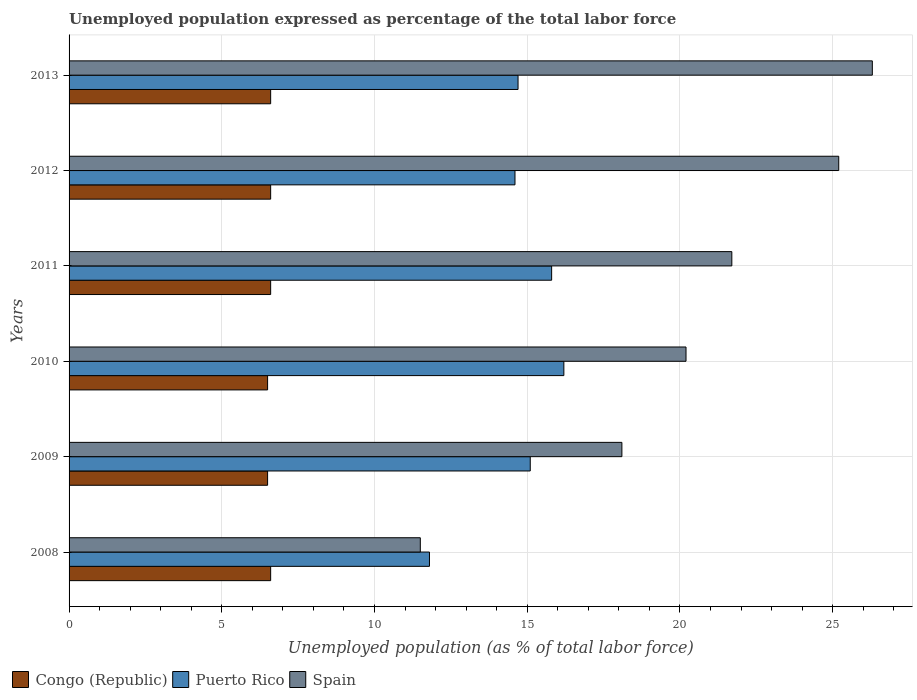Are the number of bars on each tick of the Y-axis equal?
Ensure brevity in your answer.  Yes. How many bars are there on the 3rd tick from the top?
Offer a very short reply. 3. How many bars are there on the 1st tick from the bottom?
Offer a terse response. 3. What is the unemployment in in Puerto Rico in 2012?
Offer a very short reply. 14.6. Across all years, what is the maximum unemployment in in Congo (Republic)?
Your answer should be compact. 6.6. In which year was the unemployment in in Puerto Rico maximum?
Offer a very short reply. 2010. In which year was the unemployment in in Spain minimum?
Offer a terse response. 2008. What is the total unemployment in in Puerto Rico in the graph?
Your answer should be very brief. 88.2. What is the difference between the unemployment in in Spain in 2008 and that in 2010?
Give a very brief answer. -8.7. What is the difference between the unemployment in in Puerto Rico in 2010 and the unemployment in in Spain in 2009?
Your answer should be compact. -1.9. What is the average unemployment in in Puerto Rico per year?
Ensure brevity in your answer.  14.7. In the year 2012, what is the difference between the unemployment in in Puerto Rico and unemployment in in Congo (Republic)?
Your answer should be compact. 8. What is the ratio of the unemployment in in Puerto Rico in 2011 to that in 2012?
Provide a succinct answer. 1.08. Is the unemployment in in Puerto Rico in 2008 less than that in 2012?
Your answer should be compact. Yes. What is the difference between the highest and the lowest unemployment in in Spain?
Your answer should be very brief. 14.8. In how many years, is the unemployment in in Spain greater than the average unemployment in in Spain taken over all years?
Offer a terse response. 3. What does the 2nd bar from the top in 2008 represents?
Make the answer very short. Puerto Rico. What does the 2nd bar from the bottom in 2010 represents?
Your answer should be very brief. Puerto Rico. How many bars are there?
Your response must be concise. 18. How many years are there in the graph?
Make the answer very short. 6. What is the difference between two consecutive major ticks on the X-axis?
Provide a succinct answer. 5. Where does the legend appear in the graph?
Provide a succinct answer. Bottom left. How many legend labels are there?
Keep it short and to the point. 3. What is the title of the graph?
Give a very brief answer. Unemployed population expressed as percentage of the total labor force. Does "Austria" appear as one of the legend labels in the graph?
Offer a terse response. No. What is the label or title of the X-axis?
Make the answer very short. Unemployed population (as % of total labor force). What is the Unemployed population (as % of total labor force) of Congo (Republic) in 2008?
Keep it short and to the point. 6.6. What is the Unemployed population (as % of total labor force) in Puerto Rico in 2008?
Offer a very short reply. 11.8. What is the Unemployed population (as % of total labor force) of Spain in 2008?
Your answer should be very brief. 11.5. What is the Unemployed population (as % of total labor force) in Puerto Rico in 2009?
Make the answer very short. 15.1. What is the Unemployed population (as % of total labor force) of Spain in 2009?
Your answer should be very brief. 18.1. What is the Unemployed population (as % of total labor force) of Puerto Rico in 2010?
Provide a short and direct response. 16.2. What is the Unemployed population (as % of total labor force) in Spain in 2010?
Make the answer very short. 20.2. What is the Unemployed population (as % of total labor force) of Congo (Republic) in 2011?
Your answer should be compact. 6.6. What is the Unemployed population (as % of total labor force) in Puerto Rico in 2011?
Offer a terse response. 15.8. What is the Unemployed population (as % of total labor force) in Spain in 2011?
Make the answer very short. 21.7. What is the Unemployed population (as % of total labor force) in Congo (Republic) in 2012?
Your answer should be very brief. 6.6. What is the Unemployed population (as % of total labor force) of Puerto Rico in 2012?
Your answer should be very brief. 14.6. What is the Unemployed population (as % of total labor force) in Spain in 2012?
Give a very brief answer. 25.2. What is the Unemployed population (as % of total labor force) of Congo (Republic) in 2013?
Offer a terse response. 6.6. What is the Unemployed population (as % of total labor force) in Puerto Rico in 2013?
Your response must be concise. 14.7. What is the Unemployed population (as % of total labor force) of Spain in 2013?
Ensure brevity in your answer.  26.3. Across all years, what is the maximum Unemployed population (as % of total labor force) of Congo (Republic)?
Your answer should be compact. 6.6. Across all years, what is the maximum Unemployed population (as % of total labor force) of Puerto Rico?
Keep it short and to the point. 16.2. Across all years, what is the maximum Unemployed population (as % of total labor force) of Spain?
Provide a short and direct response. 26.3. Across all years, what is the minimum Unemployed population (as % of total labor force) of Congo (Republic)?
Your answer should be compact. 6.5. Across all years, what is the minimum Unemployed population (as % of total labor force) of Puerto Rico?
Your response must be concise. 11.8. What is the total Unemployed population (as % of total labor force) of Congo (Republic) in the graph?
Make the answer very short. 39.4. What is the total Unemployed population (as % of total labor force) in Puerto Rico in the graph?
Your response must be concise. 88.2. What is the total Unemployed population (as % of total labor force) of Spain in the graph?
Provide a short and direct response. 123. What is the difference between the Unemployed population (as % of total labor force) in Spain in 2008 and that in 2009?
Make the answer very short. -6.6. What is the difference between the Unemployed population (as % of total labor force) of Congo (Republic) in 2008 and that in 2010?
Make the answer very short. 0.1. What is the difference between the Unemployed population (as % of total labor force) of Spain in 2008 and that in 2010?
Your response must be concise. -8.7. What is the difference between the Unemployed population (as % of total labor force) of Congo (Republic) in 2008 and that in 2011?
Your response must be concise. 0. What is the difference between the Unemployed population (as % of total labor force) in Puerto Rico in 2008 and that in 2012?
Offer a very short reply. -2.8. What is the difference between the Unemployed population (as % of total labor force) of Spain in 2008 and that in 2012?
Give a very brief answer. -13.7. What is the difference between the Unemployed population (as % of total labor force) in Congo (Republic) in 2008 and that in 2013?
Your answer should be compact. 0. What is the difference between the Unemployed population (as % of total labor force) in Puerto Rico in 2008 and that in 2013?
Your answer should be compact. -2.9. What is the difference between the Unemployed population (as % of total labor force) of Spain in 2008 and that in 2013?
Your answer should be very brief. -14.8. What is the difference between the Unemployed population (as % of total labor force) of Congo (Republic) in 2009 and that in 2010?
Offer a terse response. 0. What is the difference between the Unemployed population (as % of total labor force) in Puerto Rico in 2009 and that in 2010?
Provide a short and direct response. -1.1. What is the difference between the Unemployed population (as % of total labor force) of Spain in 2009 and that in 2010?
Ensure brevity in your answer.  -2.1. What is the difference between the Unemployed population (as % of total labor force) of Congo (Republic) in 2009 and that in 2011?
Give a very brief answer. -0.1. What is the difference between the Unemployed population (as % of total labor force) in Puerto Rico in 2009 and that in 2011?
Ensure brevity in your answer.  -0.7. What is the difference between the Unemployed population (as % of total labor force) of Puerto Rico in 2009 and that in 2012?
Provide a succinct answer. 0.5. What is the difference between the Unemployed population (as % of total labor force) of Spain in 2009 and that in 2012?
Your response must be concise. -7.1. What is the difference between the Unemployed population (as % of total labor force) of Spain in 2009 and that in 2013?
Your answer should be compact. -8.2. What is the difference between the Unemployed population (as % of total labor force) of Congo (Republic) in 2010 and that in 2012?
Ensure brevity in your answer.  -0.1. What is the difference between the Unemployed population (as % of total labor force) of Puerto Rico in 2010 and that in 2012?
Your response must be concise. 1.6. What is the difference between the Unemployed population (as % of total labor force) in Congo (Republic) in 2010 and that in 2013?
Your answer should be compact. -0.1. What is the difference between the Unemployed population (as % of total labor force) in Spain in 2010 and that in 2013?
Keep it short and to the point. -6.1. What is the difference between the Unemployed population (as % of total labor force) in Congo (Republic) in 2011 and that in 2012?
Your answer should be compact. 0. What is the difference between the Unemployed population (as % of total labor force) in Puerto Rico in 2011 and that in 2012?
Make the answer very short. 1.2. What is the difference between the Unemployed population (as % of total labor force) of Congo (Republic) in 2011 and that in 2013?
Provide a short and direct response. 0. What is the difference between the Unemployed population (as % of total labor force) of Puerto Rico in 2011 and that in 2013?
Your response must be concise. 1.1. What is the difference between the Unemployed population (as % of total labor force) in Spain in 2011 and that in 2013?
Ensure brevity in your answer.  -4.6. What is the difference between the Unemployed population (as % of total labor force) in Congo (Republic) in 2012 and that in 2013?
Make the answer very short. 0. What is the difference between the Unemployed population (as % of total labor force) of Congo (Republic) in 2008 and the Unemployed population (as % of total labor force) of Spain in 2009?
Provide a short and direct response. -11.5. What is the difference between the Unemployed population (as % of total labor force) in Congo (Republic) in 2008 and the Unemployed population (as % of total labor force) in Puerto Rico in 2010?
Ensure brevity in your answer.  -9.6. What is the difference between the Unemployed population (as % of total labor force) in Congo (Republic) in 2008 and the Unemployed population (as % of total labor force) in Spain in 2010?
Keep it short and to the point. -13.6. What is the difference between the Unemployed population (as % of total labor force) of Congo (Republic) in 2008 and the Unemployed population (as % of total labor force) of Puerto Rico in 2011?
Provide a short and direct response. -9.2. What is the difference between the Unemployed population (as % of total labor force) in Congo (Republic) in 2008 and the Unemployed population (as % of total labor force) in Spain in 2011?
Keep it short and to the point. -15.1. What is the difference between the Unemployed population (as % of total labor force) in Puerto Rico in 2008 and the Unemployed population (as % of total labor force) in Spain in 2011?
Offer a very short reply. -9.9. What is the difference between the Unemployed population (as % of total labor force) of Congo (Republic) in 2008 and the Unemployed population (as % of total labor force) of Puerto Rico in 2012?
Provide a succinct answer. -8. What is the difference between the Unemployed population (as % of total labor force) in Congo (Republic) in 2008 and the Unemployed population (as % of total labor force) in Spain in 2012?
Make the answer very short. -18.6. What is the difference between the Unemployed population (as % of total labor force) of Puerto Rico in 2008 and the Unemployed population (as % of total labor force) of Spain in 2012?
Your answer should be very brief. -13.4. What is the difference between the Unemployed population (as % of total labor force) of Congo (Republic) in 2008 and the Unemployed population (as % of total labor force) of Spain in 2013?
Your response must be concise. -19.7. What is the difference between the Unemployed population (as % of total labor force) in Puerto Rico in 2008 and the Unemployed population (as % of total labor force) in Spain in 2013?
Provide a short and direct response. -14.5. What is the difference between the Unemployed population (as % of total labor force) of Congo (Republic) in 2009 and the Unemployed population (as % of total labor force) of Puerto Rico in 2010?
Offer a very short reply. -9.7. What is the difference between the Unemployed population (as % of total labor force) in Congo (Republic) in 2009 and the Unemployed population (as % of total labor force) in Spain in 2010?
Give a very brief answer. -13.7. What is the difference between the Unemployed population (as % of total labor force) in Puerto Rico in 2009 and the Unemployed population (as % of total labor force) in Spain in 2010?
Give a very brief answer. -5.1. What is the difference between the Unemployed population (as % of total labor force) in Congo (Republic) in 2009 and the Unemployed population (as % of total labor force) in Spain in 2011?
Offer a terse response. -15.2. What is the difference between the Unemployed population (as % of total labor force) in Congo (Republic) in 2009 and the Unemployed population (as % of total labor force) in Puerto Rico in 2012?
Offer a very short reply. -8.1. What is the difference between the Unemployed population (as % of total labor force) of Congo (Republic) in 2009 and the Unemployed population (as % of total labor force) of Spain in 2012?
Offer a very short reply. -18.7. What is the difference between the Unemployed population (as % of total labor force) of Congo (Republic) in 2009 and the Unemployed population (as % of total labor force) of Puerto Rico in 2013?
Provide a short and direct response. -8.2. What is the difference between the Unemployed population (as % of total labor force) of Congo (Republic) in 2009 and the Unemployed population (as % of total labor force) of Spain in 2013?
Ensure brevity in your answer.  -19.8. What is the difference between the Unemployed population (as % of total labor force) in Puerto Rico in 2009 and the Unemployed population (as % of total labor force) in Spain in 2013?
Your answer should be compact. -11.2. What is the difference between the Unemployed population (as % of total labor force) in Congo (Republic) in 2010 and the Unemployed population (as % of total labor force) in Puerto Rico in 2011?
Provide a succinct answer. -9.3. What is the difference between the Unemployed population (as % of total labor force) of Congo (Republic) in 2010 and the Unemployed population (as % of total labor force) of Spain in 2011?
Offer a very short reply. -15.2. What is the difference between the Unemployed population (as % of total labor force) of Congo (Republic) in 2010 and the Unemployed population (as % of total labor force) of Puerto Rico in 2012?
Provide a succinct answer. -8.1. What is the difference between the Unemployed population (as % of total labor force) of Congo (Republic) in 2010 and the Unemployed population (as % of total labor force) of Spain in 2012?
Give a very brief answer. -18.7. What is the difference between the Unemployed population (as % of total labor force) of Puerto Rico in 2010 and the Unemployed population (as % of total labor force) of Spain in 2012?
Provide a short and direct response. -9. What is the difference between the Unemployed population (as % of total labor force) of Congo (Republic) in 2010 and the Unemployed population (as % of total labor force) of Puerto Rico in 2013?
Give a very brief answer. -8.2. What is the difference between the Unemployed population (as % of total labor force) in Congo (Republic) in 2010 and the Unemployed population (as % of total labor force) in Spain in 2013?
Offer a terse response. -19.8. What is the difference between the Unemployed population (as % of total labor force) of Puerto Rico in 2010 and the Unemployed population (as % of total labor force) of Spain in 2013?
Your answer should be compact. -10.1. What is the difference between the Unemployed population (as % of total labor force) in Congo (Republic) in 2011 and the Unemployed population (as % of total labor force) in Spain in 2012?
Offer a terse response. -18.6. What is the difference between the Unemployed population (as % of total labor force) of Congo (Republic) in 2011 and the Unemployed population (as % of total labor force) of Puerto Rico in 2013?
Offer a terse response. -8.1. What is the difference between the Unemployed population (as % of total labor force) of Congo (Republic) in 2011 and the Unemployed population (as % of total labor force) of Spain in 2013?
Keep it short and to the point. -19.7. What is the difference between the Unemployed population (as % of total labor force) in Puerto Rico in 2011 and the Unemployed population (as % of total labor force) in Spain in 2013?
Keep it short and to the point. -10.5. What is the difference between the Unemployed population (as % of total labor force) in Congo (Republic) in 2012 and the Unemployed population (as % of total labor force) in Spain in 2013?
Provide a succinct answer. -19.7. What is the difference between the Unemployed population (as % of total labor force) in Puerto Rico in 2012 and the Unemployed population (as % of total labor force) in Spain in 2013?
Your answer should be compact. -11.7. What is the average Unemployed population (as % of total labor force) of Congo (Republic) per year?
Give a very brief answer. 6.57. What is the average Unemployed population (as % of total labor force) of Puerto Rico per year?
Ensure brevity in your answer.  14.7. In the year 2008, what is the difference between the Unemployed population (as % of total labor force) of Congo (Republic) and Unemployed population (as % of total labor force) of Spain?
Provide a short and direct response. -4.9. In the year 2008, what is the difference between the Unemployed population (as % of total labor force) of Puerto Rico and Unemployed population (as % of total labor force) of Spain?
Keep it short and to the point. 0.3. In the year 2009, what is the difference between the Unemployed population (as % of total labor force) in Congo (Republic) and Unemployed population (as % of total labor force) in Puerto Rico?
Your response must be concise. -8.6. In the year 2009, what is the difference between the Unemployed population (as % of total labor force) of Congo (Republic) and Unemployed population (as % of total labor force) of Spain?
Provide a succinct answer. -11.6. In the year 2010, what is the difference between the Unemployed population (as % of total labor force) in Congo (Republic) and Unemployed population (as % of total labor force) in Puerto Rico?
Your answer should be very brief. -9.7. In the year 2010, what is the difference between the Unemployed population (as % of total labor force) in Congo (Republic) and Unemployed population (as % of total labor force) in Spain?
Your response must be concise. -13.7. In the year 2010, what is the difference between the Unemployed population (as % of total labor force) in Puerto Rico and Unemployed population (as % of total labor force) in Spain?
Offer a terse response. -4. In the year 2011, what is the difference between the Unemployed population (as % of total labor force) of Congo (Republic) and Unemployed population (as % of total labor force) of Puerto Rico?
Keep it short and to the point. -9.2. In the year 2011, what is the difference between the Unemployed population (as % of total labor force) of Congo (Republic) and Unemployed population (as % of total labor force) of Spain?
Your answer should be compact. -15.1. In the year 2012, what is the difference between the Unemployed population (as % of total labor force) in Congo (Republic) and Unemployed population (as % of total labor force) in Puerto Rico?
Make the answer very short. -8. In the year 2012, what is the difference between the Unemployed population (as % of total labor force) in Congo (Republic) and Unemployed population (as % of total labor force) in Spain?
Your response must be concise. -18.6. In the year 2012, what is the difference between the Unemployed population (as % of total labor force) of Puerto Rico and Unemployed population (as % of total labor force) of Spain?
Your answer should be very brief. -10.6. In the year 2013, what is the difference between the Unemployed population (as % of total labor force) in Congo (Republic) and Unemployed population (as % of total labor force) in Puerto Rico?
Keep it short and to the point. -8.1. In the year 2013, what is the difference between the Unemployed population (as % of total labor force) in Congo (Republic) and Unemployed population (as % of total labor force) in Spain?
Provide a succinct answer. -19.7. In the year 2013, what is the difference between the Unemployed population (as % of total labor force) in Puerto Rico and Unemployed population (as % of total labor force) in Spain?
Provide a short and direct response. -11.6. What is the ratio of the Unemployed population (as % of total labor force) in Congo (Republic) in 2008 to that in 2009?
Ensure brevity in your answer.  1.02. What is the ratio of the Unemployed population (as % of total labor force) in Puerto Rico in 2008 to that in 2009?
Your answer should be compact. 0.78. What is the ratio of the Unemployed population (as % of total labor force) in Spain in 2008 to that in 2009?
Your answer should be compact. 0.64. What is the ratio of the Unemployed population (as % of total labor force) of Congo (Republic) in 2008 to that in 2010?
Make the answer very short. 1.02. What is the ratio of the Unemployed population (as % of total labor force) of Puerto Rico in 2008 to that in 2010?
Offer a very short reply. 0.73. What is the ratio of the Unemployed population (as % of total labor force) in Spain in 2008 to that in 2010?
Make the answer very short. 0.57. What is the ratio of the Unemployed population (as % of total labor force) in Puerto Rico in 2008 to that in 2011?
Provide a short and direct response. 0.75. What is the ratio of the Unemployed population (as % of total labor force) of Spain in 2008 to that in 2011?
Keep it short and to the point. 0.53. What is the ratio of the Unemployed population (as % of total labor force) of Puerto Rico in 2008 to that in 2012?
Ensure brevity in your answer.  0.81. What is the ratio of the Unemployed population (as % of total labor force) of Spain in 2008 to that in 2012?
Ensure brevity in your answer.  0.46. What is the ratio of the Unemployed population (as % of total labor force) of Congo (Republic) in 2008 to that in 2013?
Your answer should be very brief. 1. What is the ratio of the Unemployed population (as % of total labor force) of Puerto Rico in 2008 to that in 2013?
Offer a very short reply. 0.8. What is the ratio of the Unemployed population (as % of total labor force) of Spain in 2008 to that in 2013?
Make the answer very short. 0.44. What is the ratio of the Unemployed population (as % of total labor force) in Puerto Rico in 2009 to that in 2010?
Your answer should be very brief. 0.93. What is the ratio of the Unemployed population (as % of total labor force) in Spain in 2009 to that in 2010?
Keep it short and to the point. 0.9. What is the ratio of the Unemployed population (as % of total labor force) of Puerto Rico in 2009 to that in 2011?
Offer a very short reply. 0.96. What is the ratio of the Unemployed population (as % of total labor force) in Spain in 2009 to that in 2011?
Offer a terse response. 0.83. What is the ratio of the Unemployed population (as % of total labor force) of Puerto Rico in 2009 to that in 2012?
Make the answer very short. 1.03. What is the ratio of the Unemployed population (as % of total labor force) of Spain in 2009 to that in 2012?
Make the answer very short. 0.72. What is the ratio of the Unemployed population (as % of total labor force) of Congo (Republic) in 2009 to that in 2013?
Offer a terse response. 0.98. What is the ratio of the Unemployed population (as % of total labor force) in Puerto Rico in 2009 to that in 2013?
Make the answer very short. 1.03. What is the ratio of the Unemployed population (as % of total labor force) in Spain in 2009 to that in 2013?
Provide a succinct answer. 0.69. What is the ratio of the Unemployed population (as % of total labor force) in Congo (Republic) in 2010 to that in 2011?
Provide a short and direct response. 0.98. What is the ratio of the Unemployed population (as % of total labor force) in Puerto Rico in 2010 to that in 2011?
Provide a succinct answer. 1.03. What is the ratio of the Unemployed population (as % of total labor force) of Spain in 2010 to that in 2011?
Offer a very short reply. 0.93. What is the ratio of the Unemployed population (as % of total labor force) of Puerto Rico in 2010 to that in 2012?
Your response must be concise. 1.11. What is the ratio of the Unemployed population (as % of total labor force) in Spain in 2010 to that in 2012?
Your answer should be compact. 0.8. What is the ratio of the Unemployed population (as % of total labor force) in Puerto Rico in 2010 to that in 2013?
Keep it short and to the point. 1.1. What is the ratio of the Unemployed population (as % of total labor force) of Spain in 2010 to that in 2013?
Your response must be concise. 0.77. What is the ratio of the Unemployed population (as % of total labor force) in Puerto Rico in 2011 to that in 2012?
Provide a succinct answer. 1.08. What is the ratio of the Unemployed population (as % of total labor force) of Spain in 2011 to that in 2012?
Your answer should be compact. 0.86. What is the ratio of the Unemployed population (as % of total labor force) of Puerto Rico in 2011 to that in 2013?
Give a very brief answer. 1.07. What is the ratio of the Unemployed population (as % of total labor force) in Spain in 2011 to that in 2013?
Keep it short and to the point. 0.83. What is the ratio of the Unemployed population (as % of total labor force) of Puerto Rico in 2012 to that in 2013?
Give a very brief answer. 0.99. What is the ratio of the Unemployed population (as % of total labor force) in Spain in 2012 to that in 2013?
Ensure brevity in your answer.  0.96. What is the difference between the highest and the second highest Unemployed population (as % of total labor force) in Puerto Rico?
Give a very brief answer. 0.4. What is the difference between the highest and the second highest Unemployed population (as % of total labor force) in Spain?
Offer a terse response. 1.1. What is the difference between the highest and the lowest Unemployed population (as % of total labor force) in Congo (Republic)?
Provide a succinct answer. 0.1. What is the difference between the highest and the lowest Unemployed population (as % of total labor force) in Puerto Rico?
Offer a terse response. 4.4. What is the difference between the highest and the lowest Unemployed population (as % of total labor force) in Spain?
Offer a terse response. 14.8. 